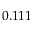<formula> <loc_0><loc_0><loc_500><loc_500>0 . 1 1 1</formula> 